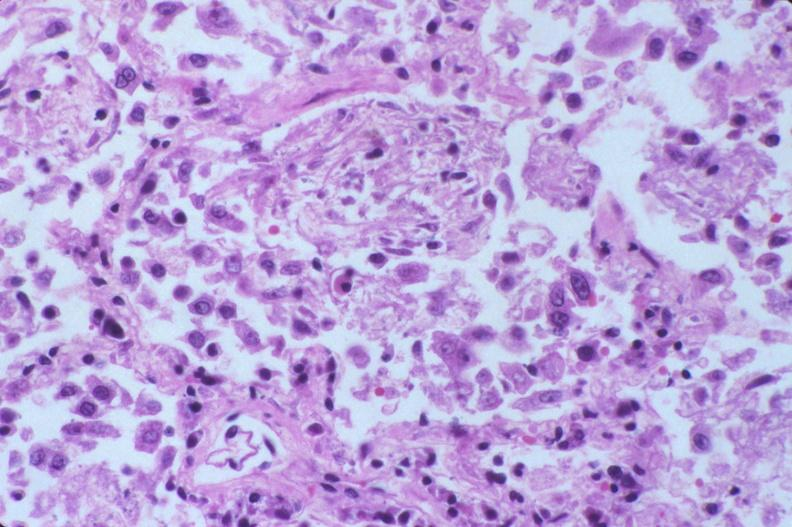what is present?
Answer the question using a single word or phrase. Respiratory 